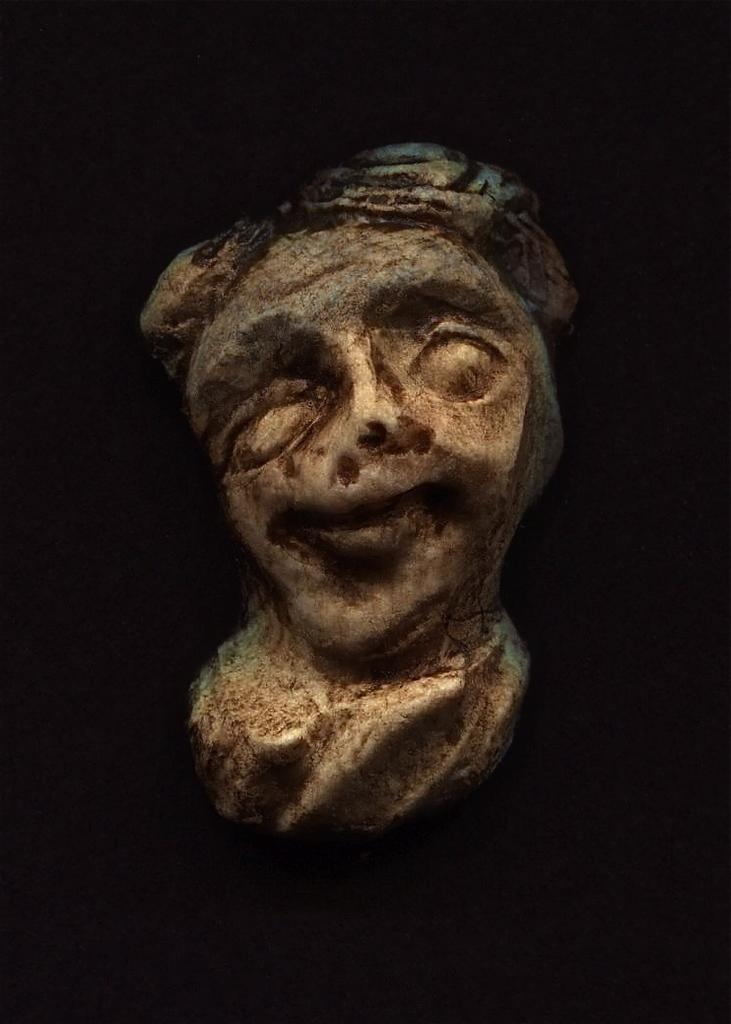What is the color of the background in the image? The background of the image is dark. What is the main subject in the middle of the image? There is a sculpture in the middle of the image. What type of magic is being performed by the sculpture in the image? There is no magic being performed by the sculpture in the image, as it is an inanimate object. What is the starting point for the step in the image? There is no step present in the image, only a sculpture and a dark background. 